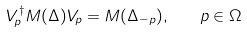<formula> <loc_0><loc_0><loc_500><loc_500>V _ { p } ^ { \dagger } M ( \Delta ) V _ { p } = M ( \Delta _ { - p } ) , \quad p \in \Omega</formula> 